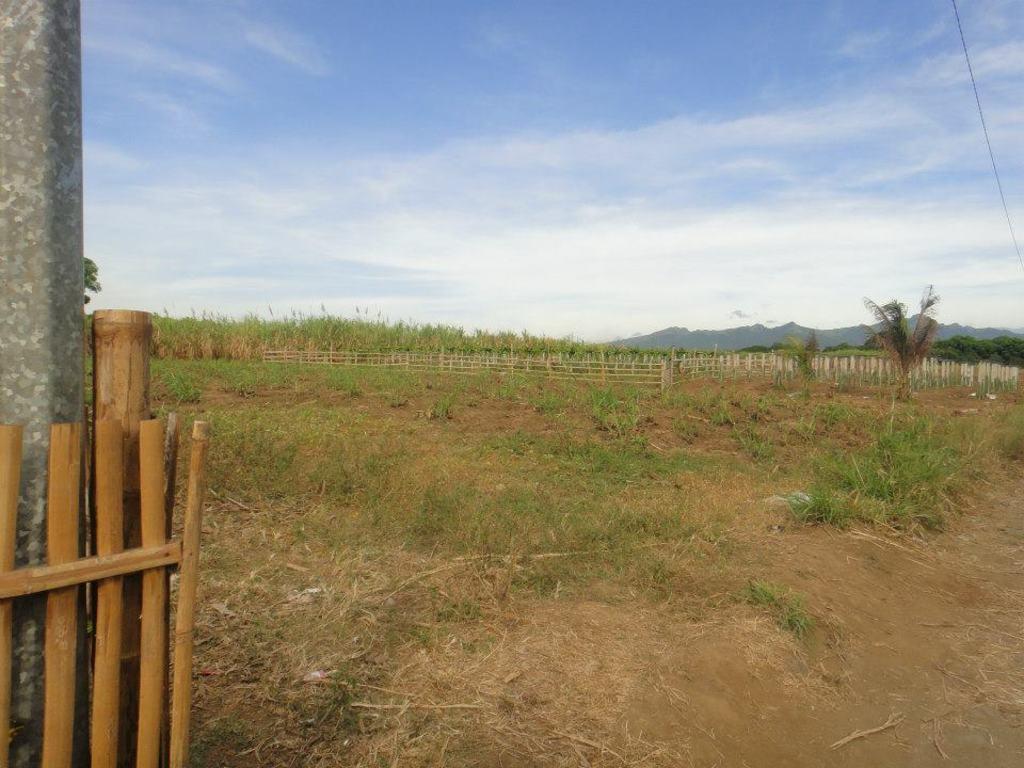Describe this image in one or two sentences. In the image we can see wooden fence, grass, metal pole, trees, hills and a cloudy pale blue sky. 